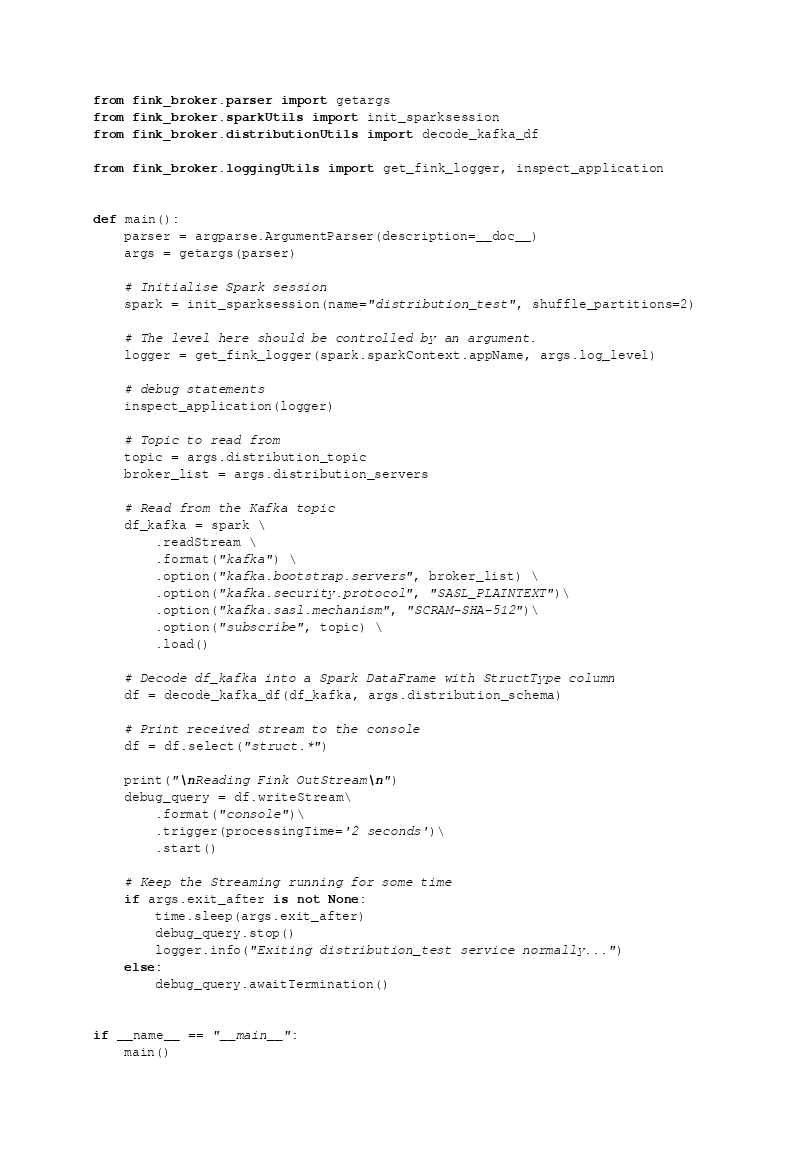Convert code to text. <code><loc_0><loc_0><loc_500><loc_500><_Python_>
from fink_broker.parser import getargs
from fink_broker.sparkUtils import init_sparksession
from fink_broker.distributionUtils import decode_kafka_df

from fink_broker.loggingUtils import get_fink_logger, inspect_application


def main():
    parser = argparse.ArgumentParser(description=__doc__)
    args = getargs(parser)

    # Initialise Spark session
    spark = init_sparksession(name="distribution_test", shuffle_partitions=2)

    # The level here should be controlled by an argument.
    logger = get_fink_logger(spark.sparkContext.appName, args.log_level)

    # debug statements
    inspect_application(logger)

    # Topic to read from
    topic = args.distribution_topic
    broker_list = args.distribution_servers

    # Read from the Kafka topic
    df_kafka = spark \
        .readStream \
        .format("kafka") \
        .option("kafka.bootstrap.servers", broker_list) \
        .option("kafka.security.protocol", "SASL_PLAINTEXT")\
        .option("kafka.sasl.mechanism", "SCRAM-SHA-512")\
        .option("subscribe", topic) \
        .load()

    # Decode df_kafka into a Spark DataFrame with StructType column
    df = decode_kafka_df(df_kafka, args.distribution_schema)

    # Print received stream to the console
    df = df.select("struct.*")

    print("\nReading Fink OutStream\n")
    debug_query = df.writeStream\
        .format("console")\
        .trigger(processingTime='2 seconds')\
        .start()

    # Keep the Streaming running for some time
    if args.exit_after is not None:
        time.sleep(args.exit_after)
        debug_query.stop()
        logger.info("Exiting distribution_test service normally...")
    else:
        debug_query.awaitTermination()


if __name__ == "__main__":
    main()
</code> 